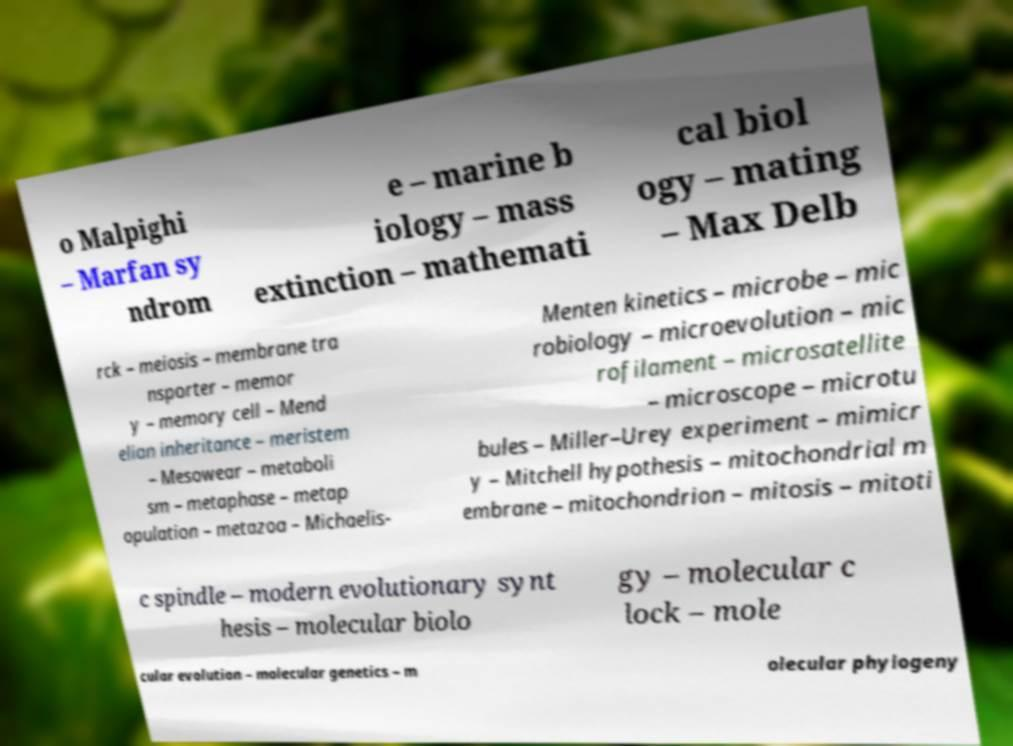Could you assist in decoding the text presented in this image and type it out clearly? o Malpighi – Marfan sy ndrom e – marine b iology – mass extinction – mathemati cal biol ogy – mating – Max Delb rck – meiosis – membrane tra nsporter – memor y – memory cell – Mend elian inheritance – meristem – Mesowear – metaboli sm – metaphase – metap opulation – metazoa – Michaelis- Menten kinetics – microbe – mic robiology – microevolution – mic rofilament – microsatellite – microscope – microtu bules – Miller–Urey experiment – mimicr y – Mitchell hypothesis – mitochondrial m embrane – mitochondrion – mitosis – mitoti c spindle – modern evolutionary synt hesis – molecular biolo gy – molecular c lock – mole cular evolution – molecular genetics – m olecular phylogeny 